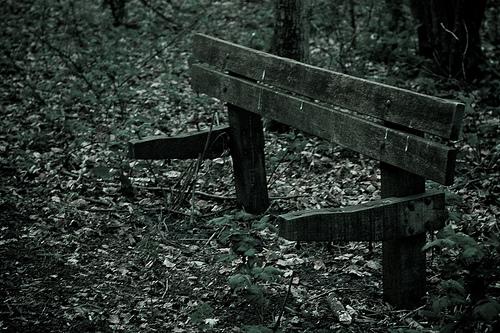Can you sit on this bench?
Answer briefly. No. What is missing from this bench?
Give a very brief answer. Seat. Why would you not want to sit on the bench right now?
Keep it brief. No seat. Is it nighttime?
Write a very short answer. Yes. Where is the bench?
Give a very brief answer. Missing. What type of material is on the ground?
Write a very short answer. Leaves. Can you see water in the picture?
Answer briefly. No. Is this a bench?
Write a very short answer. Yes. 